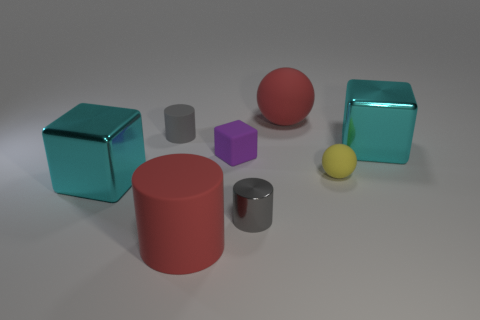Add 2 red matte balls. How many objects exist? 10 Subtract all spheres. How many objects are left? 6 Add 2 tiny gray metal cylinders. How many tiny gray metal cylinders exist? 3 Subtract 0 brown spheres. How many objects are left? 8 Subtract all tiny blue shiny things. Subtract all shiny things. How many objects are left? 5 Add 4 purple things. How many purple things are left? 5 